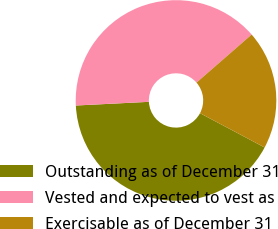<chart> <loc_0><loc_0><loc_500><loc_500><pie_chart><fcel>Outstanding as of December 31<fcel>Vested and expected to vest as<fcel>Exercisable as of December 31<nl><fcel>41.44%<fcel>39.4%<fcel>19.17%<nl></chart> 